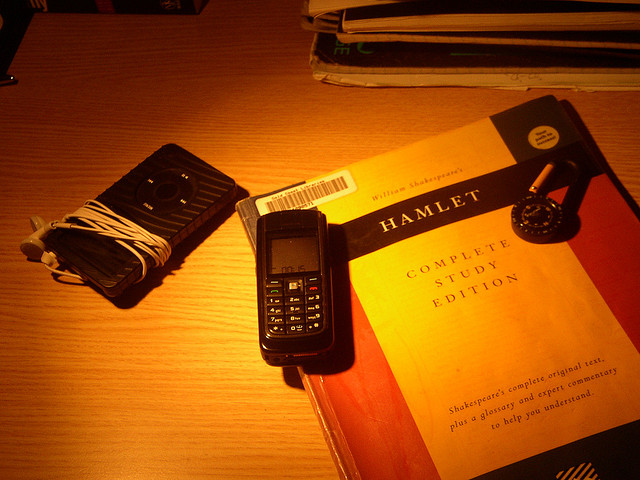Identify the text contained in this image. COMPLETE STUDY EDITION HAMLET Shakespeare's 4 help expers glossary a plus original 